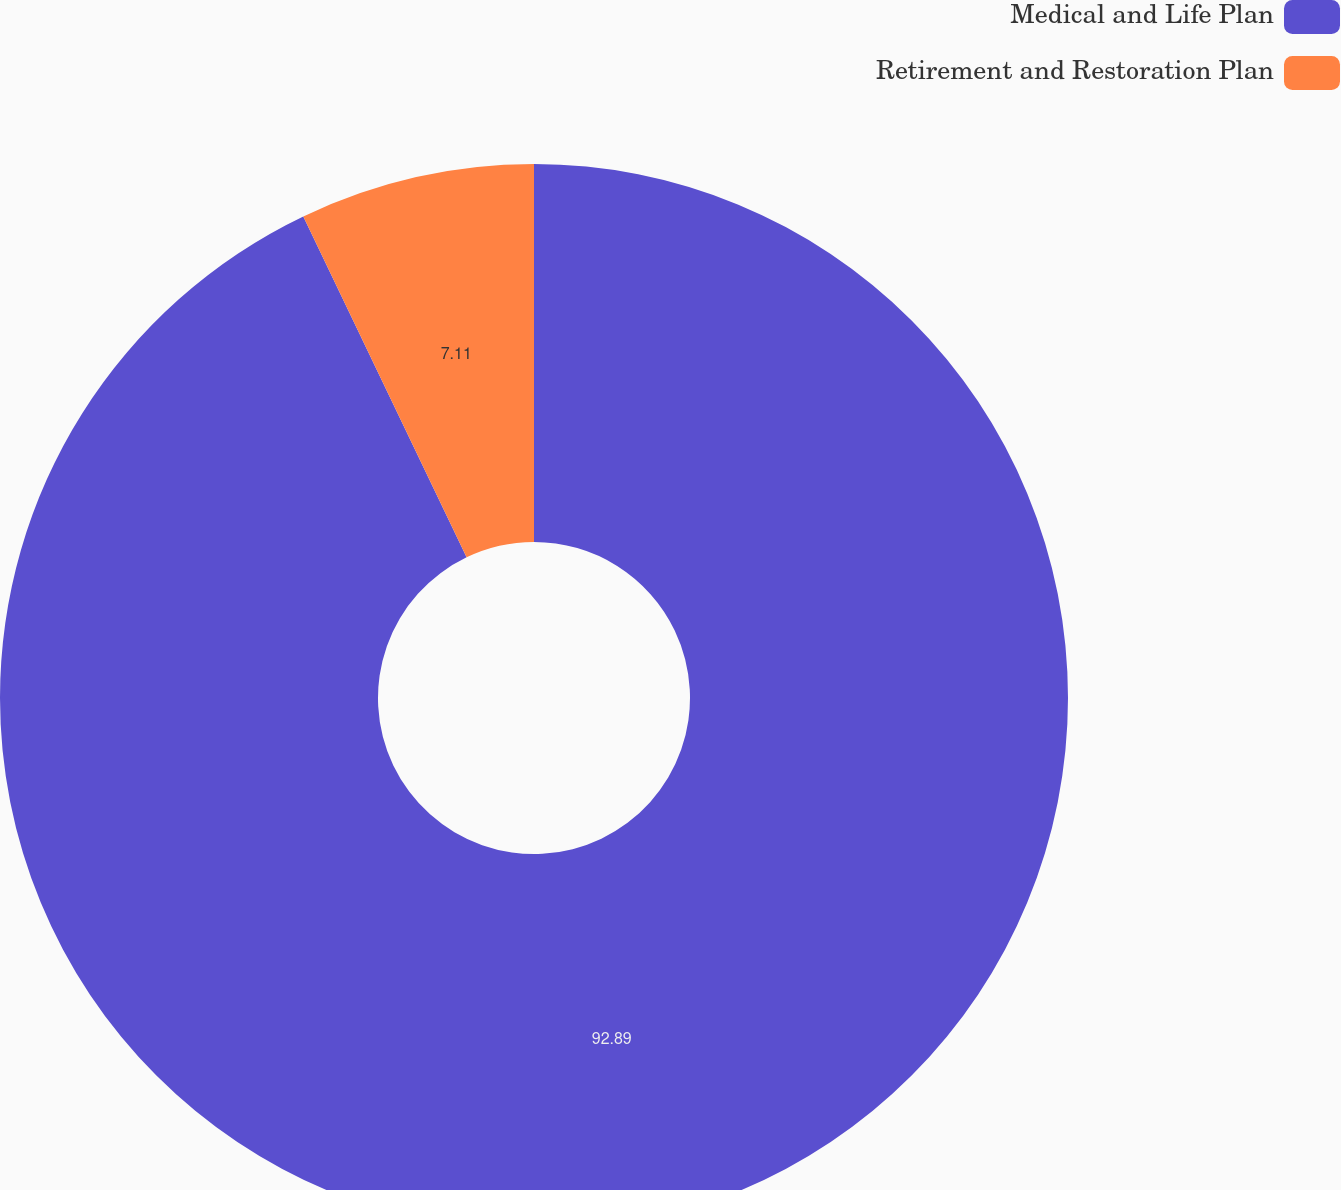<chart> <loc_0><loc_0><loc_500><loc_500><pie_chart><fcel>Medical and Life Plan<fcel>Retirement and Restoration Plan<nl><fcel>92.89%<fcel>7.11%<nl></chart> 